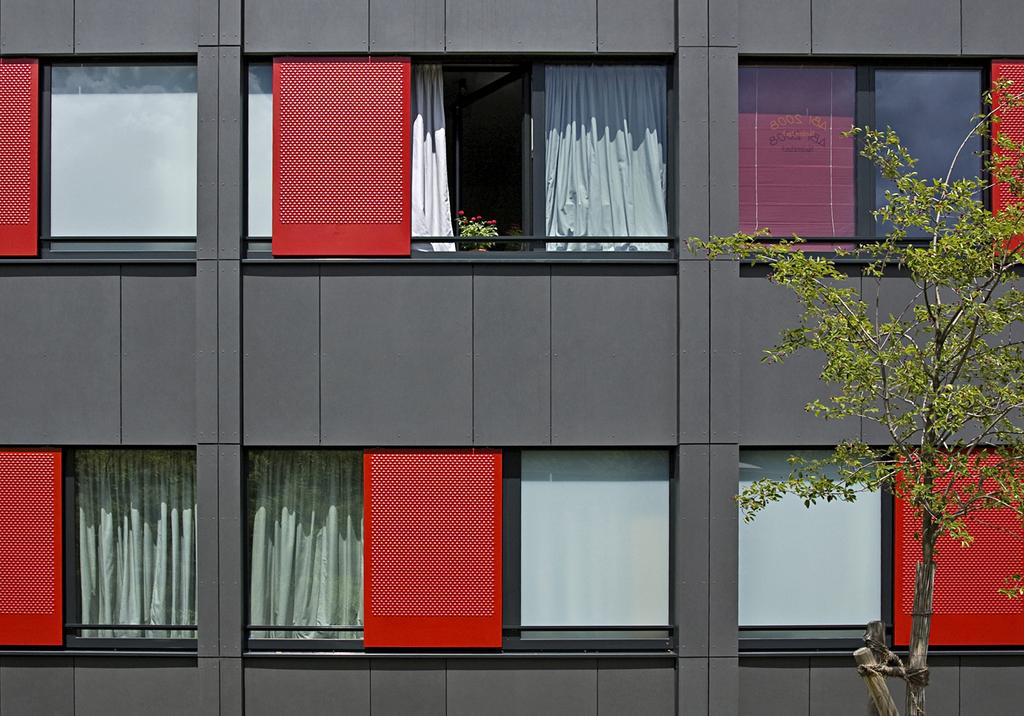What type of windows are on the building in the image? The building has glass windows. What can be seen through the windows? Curtains and a plant are visible through the windows. What is located in front of the building? There is a tree in front of the building. What color is the orange hanging from the tree in the image? There is no orange present in the image; it only shows a tree in front of the building. 